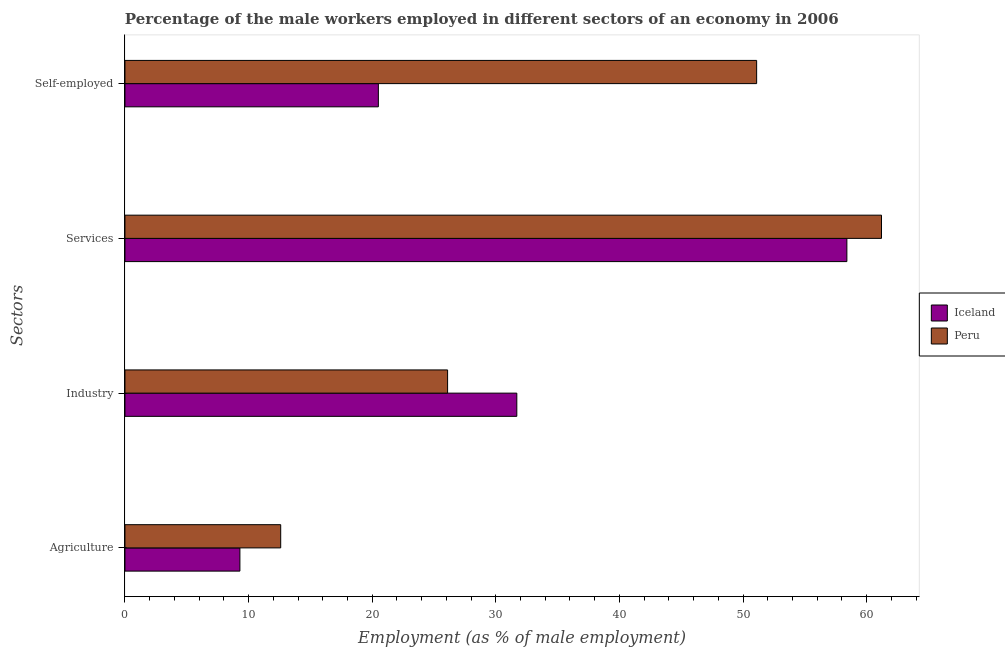How many different coloured bars are there?
Your answer should be very brief. 2. How many bars are there on the 3rd tick from the bottom?
Offer a very short reply. 2. What is the label of the 4th group of bars from the top?
Give a very brief answer. Agriculture. What is the percentage of male workers in services in Iceland?
Give a very brief answer. 58.4. Across all countries, what is the maximum percentage of male workers in services?
Offer a terse response. 61.2. Across all countries, what is the minimum percentage of male workers in agriculture?
Your answer should be compact. 9.3. In which country was the percentage of male workers in industry minimum?
Provide a succinct answer. Peru. What is the total percentage of male workers in services in the graph?
Offer a very short reply. 119.6. What is the difference between the percentage of male workers in industry in Peru and that in Iceland?
Make the answer very short. -5.6. What is the difference between the percentage of self employed male workers in Peru and the percentage of male workers in agriculture in Iceland?
Make the answer very short. 41.8. What is the average percentage of self employed male workers per country?
Provide a short and direct response. 35.8. What is the difference between the percentage of self employed male workers and percentage of male workers in services in Iceland?
Provide a succinct answer. -37.9. In how many countries, is the percentage of self employed male workers greater than 60 %?
Keep it short and to the point. 0. What is the ratio of the percentage of male workers in services in Peru to that in Iceland?
Offer a terse response. 1.05. Is the percentage of male workers in agriculture in Peru less than that in Iceland?
Keep it short and to the point. No. What is the difference between the highest and the second highest percentage of male workers in agriculture?
Keep it short and to the point. 3.3. What is the difference between the highest and the lowest percentage of male workers in industry?
Your answer should be very brief. 5.6. In how many countries, is the percentage of self employed male workers greater than the average percentage of self employed male workers taken over all countries?
Your answer should be very brief. 1. Is the sum of the percentage of male workers in services in Iceland and Peru greater than the maximum percentage of male workers in agriculture across all countries?
Provide a short and direct response. Yes. Is it the case that in every country, the sum of the percentage of male workers in industry and percentage of male workers in agriculture is greater than the sum of percentage of male workers in services and percentage of self employed male workers?
Make the answer very short. No. What does the 2nd bar from the top in Agriculture represents?
Your answer should be compact. Iceland. What does the 1st bar from the bottom in Services represents?
Keep it short and to the point. Iceland. Is it the case that in every country, the sum of the percentage of male workers in agriculture and percentage of male workers in industry is greater than the percentage of male workers in services?
Ensure brevity in your answer.  No. What is the difference between two consecutive major ticks on the X-axis?
Keep it short and to the point. 10. Are the values on the major ticks of X-axis written in scientific E-notation?
Keep it short and to the point. No. Does the graph contain grids?
Provide a short and direct response. No. How many legend labels are there?
Your answer should be very brief. 2. What is the title of the graph?
Your answer should be compact. Percentage of the male workers employed in different sectors of an economy in 2006. Does "Kuwait" appear as one of the legend labels in the graph?
Your response must be concise. No. What is the label or title of the X-axis?
Make the answer very short. Employment (as % of male employment). What is the label or title of the Y-axis?
Your answer should be very brief. Sectors. What is the Employment (as % of male employment) of Iceland in Agriculture?
Make the answer very short. 9.3. What is the Employment (as % of male employment) in Peru in Agriculture?
Give a very brief answer. 12.6. What is the Employment (as % of male employment) of Iceland in Industry?
Keep it short and to the point. 31.7. What is the Employment (as % of male employment) of Peru in Industry?
Provide a short and direct response. 26.1. What is the Employment (as % of male employment) in Iceland in Services?
Keep it short and to the point. 58.4. What is the Employment (as % of male employment) of Peru in Services?
Your answer should be compact. 61.2. What is the Employment (as % of male employment) of Iceland in Self-employed?
Keep it short and to the point. 20.5. What is the Employment (as % of male employment) of Peru in Self-employed?
Provide a short and direct response. 51.1. Across all Sectors, what is the maximum Employment (as % of male employment) in Iceland?
Ensure brevity in your answer.  58.4. Across all Sectors, what is the maximum Employment (as % of male employment) in Peru?
Your answer should be very brief. 61.2. Across all Sectors, what is the minimum Employment (as % of male employment) in Iceland?
Keep it short and to the point. 9.3. Across all Sectors, what is the minimum Employment (as % of male employment) of Peru?
Your answer should be very brief. 12.6. What is the total Employment (as % of male employment) in Iceland in the graph?
Give a very brief answer. 119.9. What is the total Employment (as % of male employment) in Peru in the graph?
Make the answer very short. 151. What is the difference between the Employment (as % of male employment) in Iceland in Agriculture and that in Industry?
Your response must be concise. -22.4. What is the difference between the Employment (as % of male employment) in Peru in Agriculture and that in Industry?
Your answer should be very brief. -13.5. What is the difference between the Employment (as % of male employment) in Iceland in Agriculture and that in Services?
Offer a very short reply. -49.1. What is the difference between the Employment (as % of male employment) of Peru in Agriculture and that in Services?
Your response must be concise. -48.6. What is the difference between the Employment (as % of male employment) in Iceland in Agriculture and that in Self-employed?
Your answer should be compact. -11.2. What is the difference between the Employment (as % of male employment) of Peru in Agriculture and that in Self-employed?
Ensure brevity in your answer.  -38.5. What is the difference between the Employment (as % of male employment) in Iceland in Industry and that in Services?
Offer a terse response. -26.7. What is the difference between the Employment (as % of male employment) of Peru in Industry and that in Services?
Offer a terse response. -35.1. What is the difference between the Employment (as % of male employment) of Iceland in Industry and that in Self-employed?
Ensure brevity in your answer.  11.2. What is the difference between the Employment (as % of male employment) in Iceland in Services and that in Self-employed?
Offer a terse response. 37.9. What is the difference between the Employment (as % of male employment) in Iceland in Agriculture and the Employment (as % of male employment) in Peru in Industry?
Provide a succinct answer. -16.8. What is the difference between the Employment (as % of male employment) of Iceland in Agriculture and the Employment (as % of male employment) of Peru in Services?
Make the answer very short. -51.9. What is the difference between the Employment (as % of male employment) in Iceland in Agriculture and the Employment (as % of male employment) in Peru in Self-employed?
Your answer should be very brief. -41.8. What is the difference between the Employment (as % of male employment) in Iceland in Industry and the Employment (as % of male employment) in Peru in Services?
Your answer should be very brief. -29.5. What is the difference between the Employment (as % of male employment) of Iceland in Industry and the Employment (as % of male employment) of Peru in Self-employed?
Ensure brevity in your answer.  -19.4. What is the difference between the Employment (as % of male employment) of Iceland in Services and the Employment (as % of male employment) of Peru in Self-employed?
Provide a succinct answer. 7.3. What is the average Employment (as % of male employment) of Iceland per Sectors?
Your response must be concise. 29.98. What is the average Employment (as % of male employment) in Peru per Sectors?
Your answer should be compact. 37.75. What is the difference between the Employment (as % of male employment) in Iceland and Employment (as % of male employment) in Peru in Agriculture?
Offer a terse response. -3.3. What is the difference between the Employment (as % of male employment) in Iceland and Employment (as % of male employment) in Peru in Self-employed?
Keep it short and to the point. -30.6. What is the ratio of the Employment (as % of male employment) of Iceland in Agriculture to that in Industry?
Keep it short and to the point. 0.29. What is the ratio of the Employment (as % of male employment) in Peru in Agriculture to that in Industry?
Ensure brevity in your answer.  0.48. What is the ratio of the Employment (as % of male employment) in Iceland in Agriculture to that in Services?
Offer a very short reply. 0.16. What is the ratio of the Employment (as % of male employment) of Peru in Agriculture to that in Services?
Make the answer very short. 0.21. What is the ratio of the Employment (as % of male employment) in Iceland in Agriculture to that in Self-employed?
Keep it short and to the point. 0.45. What is the ratio of the Employment (as % of male employment) in Peru in Agriculture to that in Self-employed?
Your answer should be compact. 0.25. What is the ratio of the Employment (as % of male employment) in Iceland in Industry to that in Services?
Your answer should be compact. 0.54. What is the ratio of the Employment (as % of male employment) in Peru in Industry to that in Services?
Provide a short and direct response. 0.43. What is the ratio of the Employment (as % of male employment) of Iceland in Industry to that in Self-employed?
Provide a succinct answer. 1.55. What is the ratio of the Employment (as % of male employment) in Peru in Industry to that in Self-employed?
Your answer should be very brief. 0.51. What is the ratio of the Employment (as % of male employment) of Iceland in Services to that in Self-employed?
Make the answer very short. 2.85. What is the ratio of the Employment (as % of male employment) of Peru in Services to that in Self-employed?
Offer a terse response. 1.2. What is the difference between the highest and the second highest Employment (as % of male employment) in Iceland?
Provide a succinct answer. 26.7. What is the difference between the highest and the second highest Employment (as % of male employment) of Peru?
Provide a short and direct response. 10.1. What is the difference between the highest and the lowest Employment (as % of male employment) in Iceland?
Give a very brief answer. 49.1. What is the difference between the highest and the lowest Employment (as % of male employment) of Peru?
Your answer should be very brief. 48.6. 